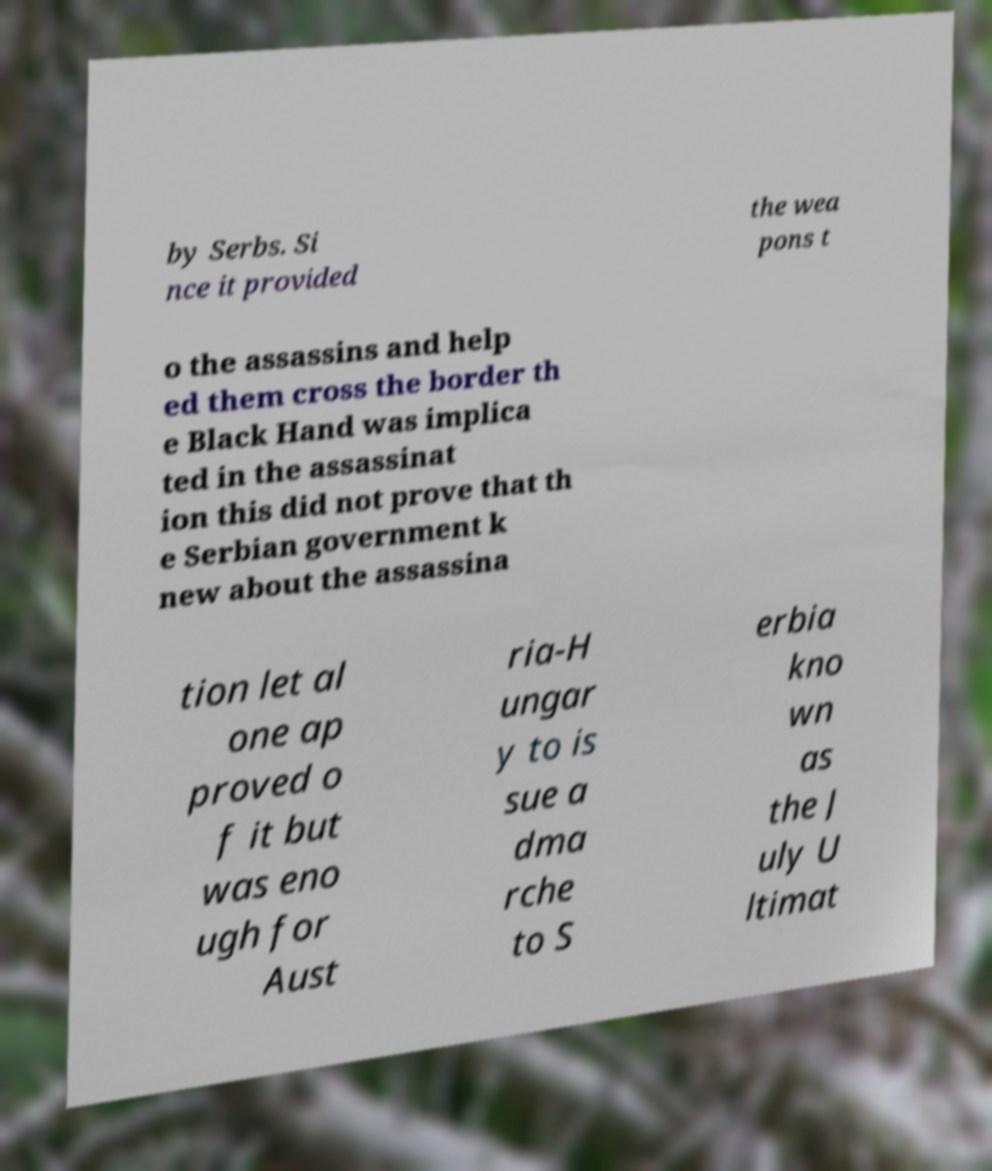Can you accurately transcribe the text from the provided image for me? by Serbs. Si nce it provided the wea pons t o the assassins and help ed them cross the border th e Black Hand was implica ted in the assassinat ion this did not prove that th e Serbian government k new about the assassina tion let al one ap proved o f it but was eno ugh for Aust ria-H ungar y to is sue a dma rche to S erbia kno wn as the J uly U ltimat 